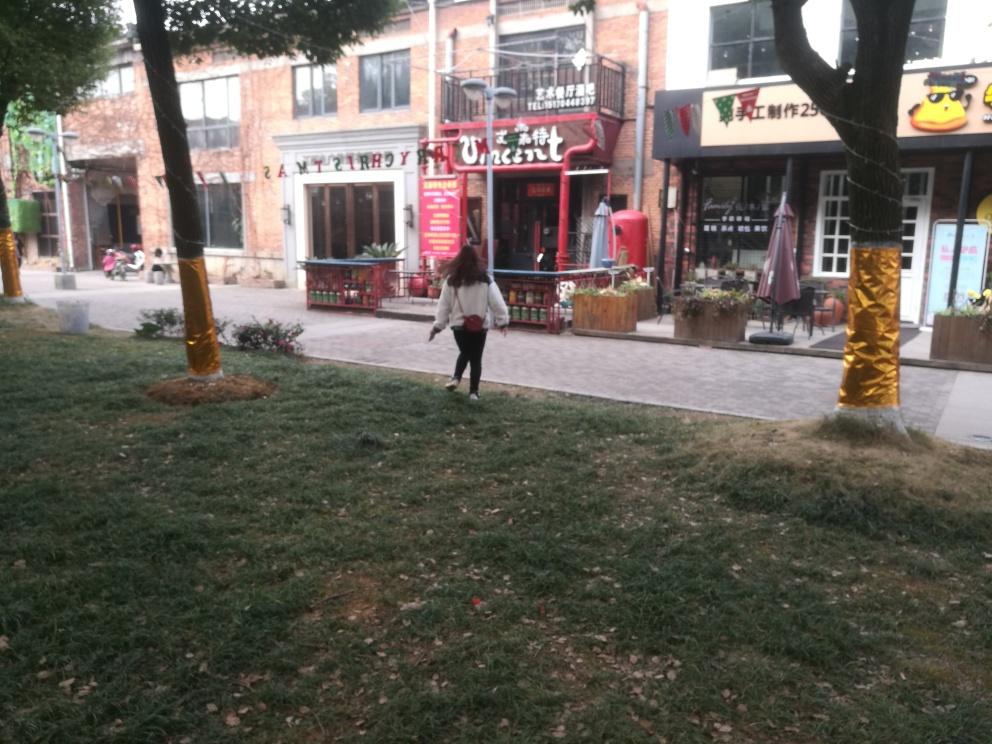Is there a person in the center of the frame? Yes, there is a person located towards the center of the frame, walking away from the viewpoint. She appears to be wearing a light-colored top with dark pants and is carrying something in her right hand. 